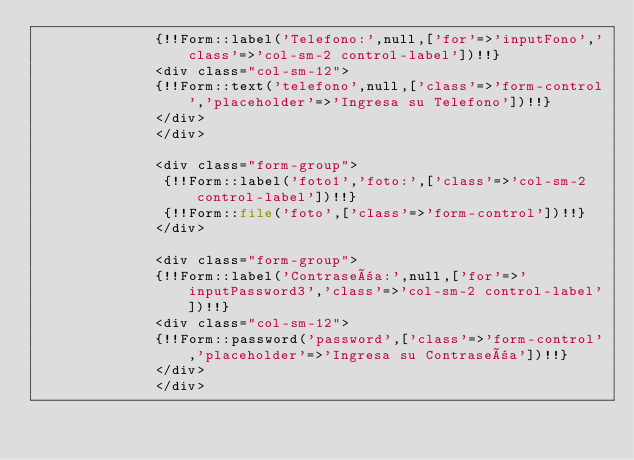<code> <loc_0><loc_0><loc_500><loc_500><_PHP_>	          {!!Form::label('Telefono:',null,['for'=>'inputFono','class'=>'col-sm-2 control-label'])!!}
	          <div class="col-sm-12">
	          {!!Form::text('telefono',null,['class'=>'form-control','placeholder'=>'Ingresa su Telefono'])!!}	
	          </div>
              </div>

              <div class="form-group">
	           {!!Form::label('foto1','foto:',['class'=>'col-sm-2 control-label'])!!}
	           {!!Form::file('foto',['class'=>'form-control'])!!}
              </div>

              <div class="form-group">
	          {!!Form::label('Contraseña:',null,['for'=>'inputPassword3','class'=>'col-sm-2 control-label'])!!}
	          <div class="col-sm-12">
	          {!!Form::password('password',['class'=>'form-control','placeholder'=>'Ingresa su Contraseña'])!!}	
	          </div>
              </div>
              
        </code> 